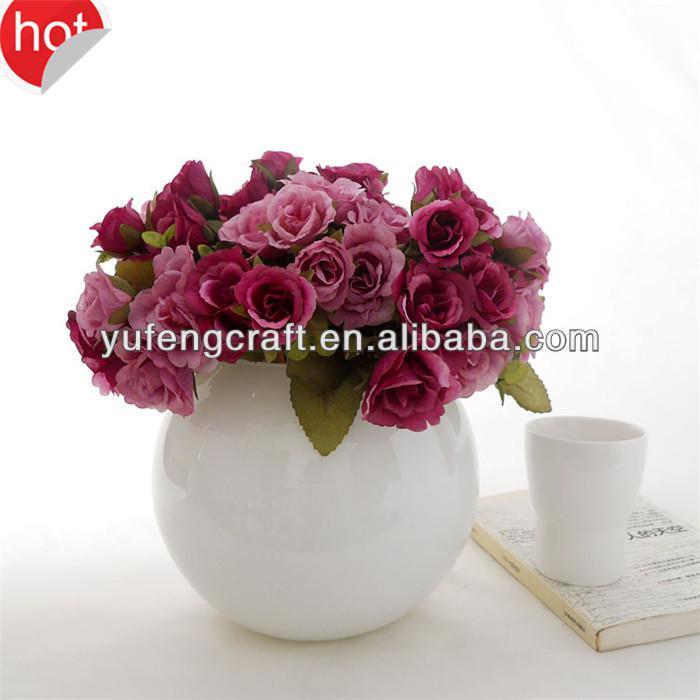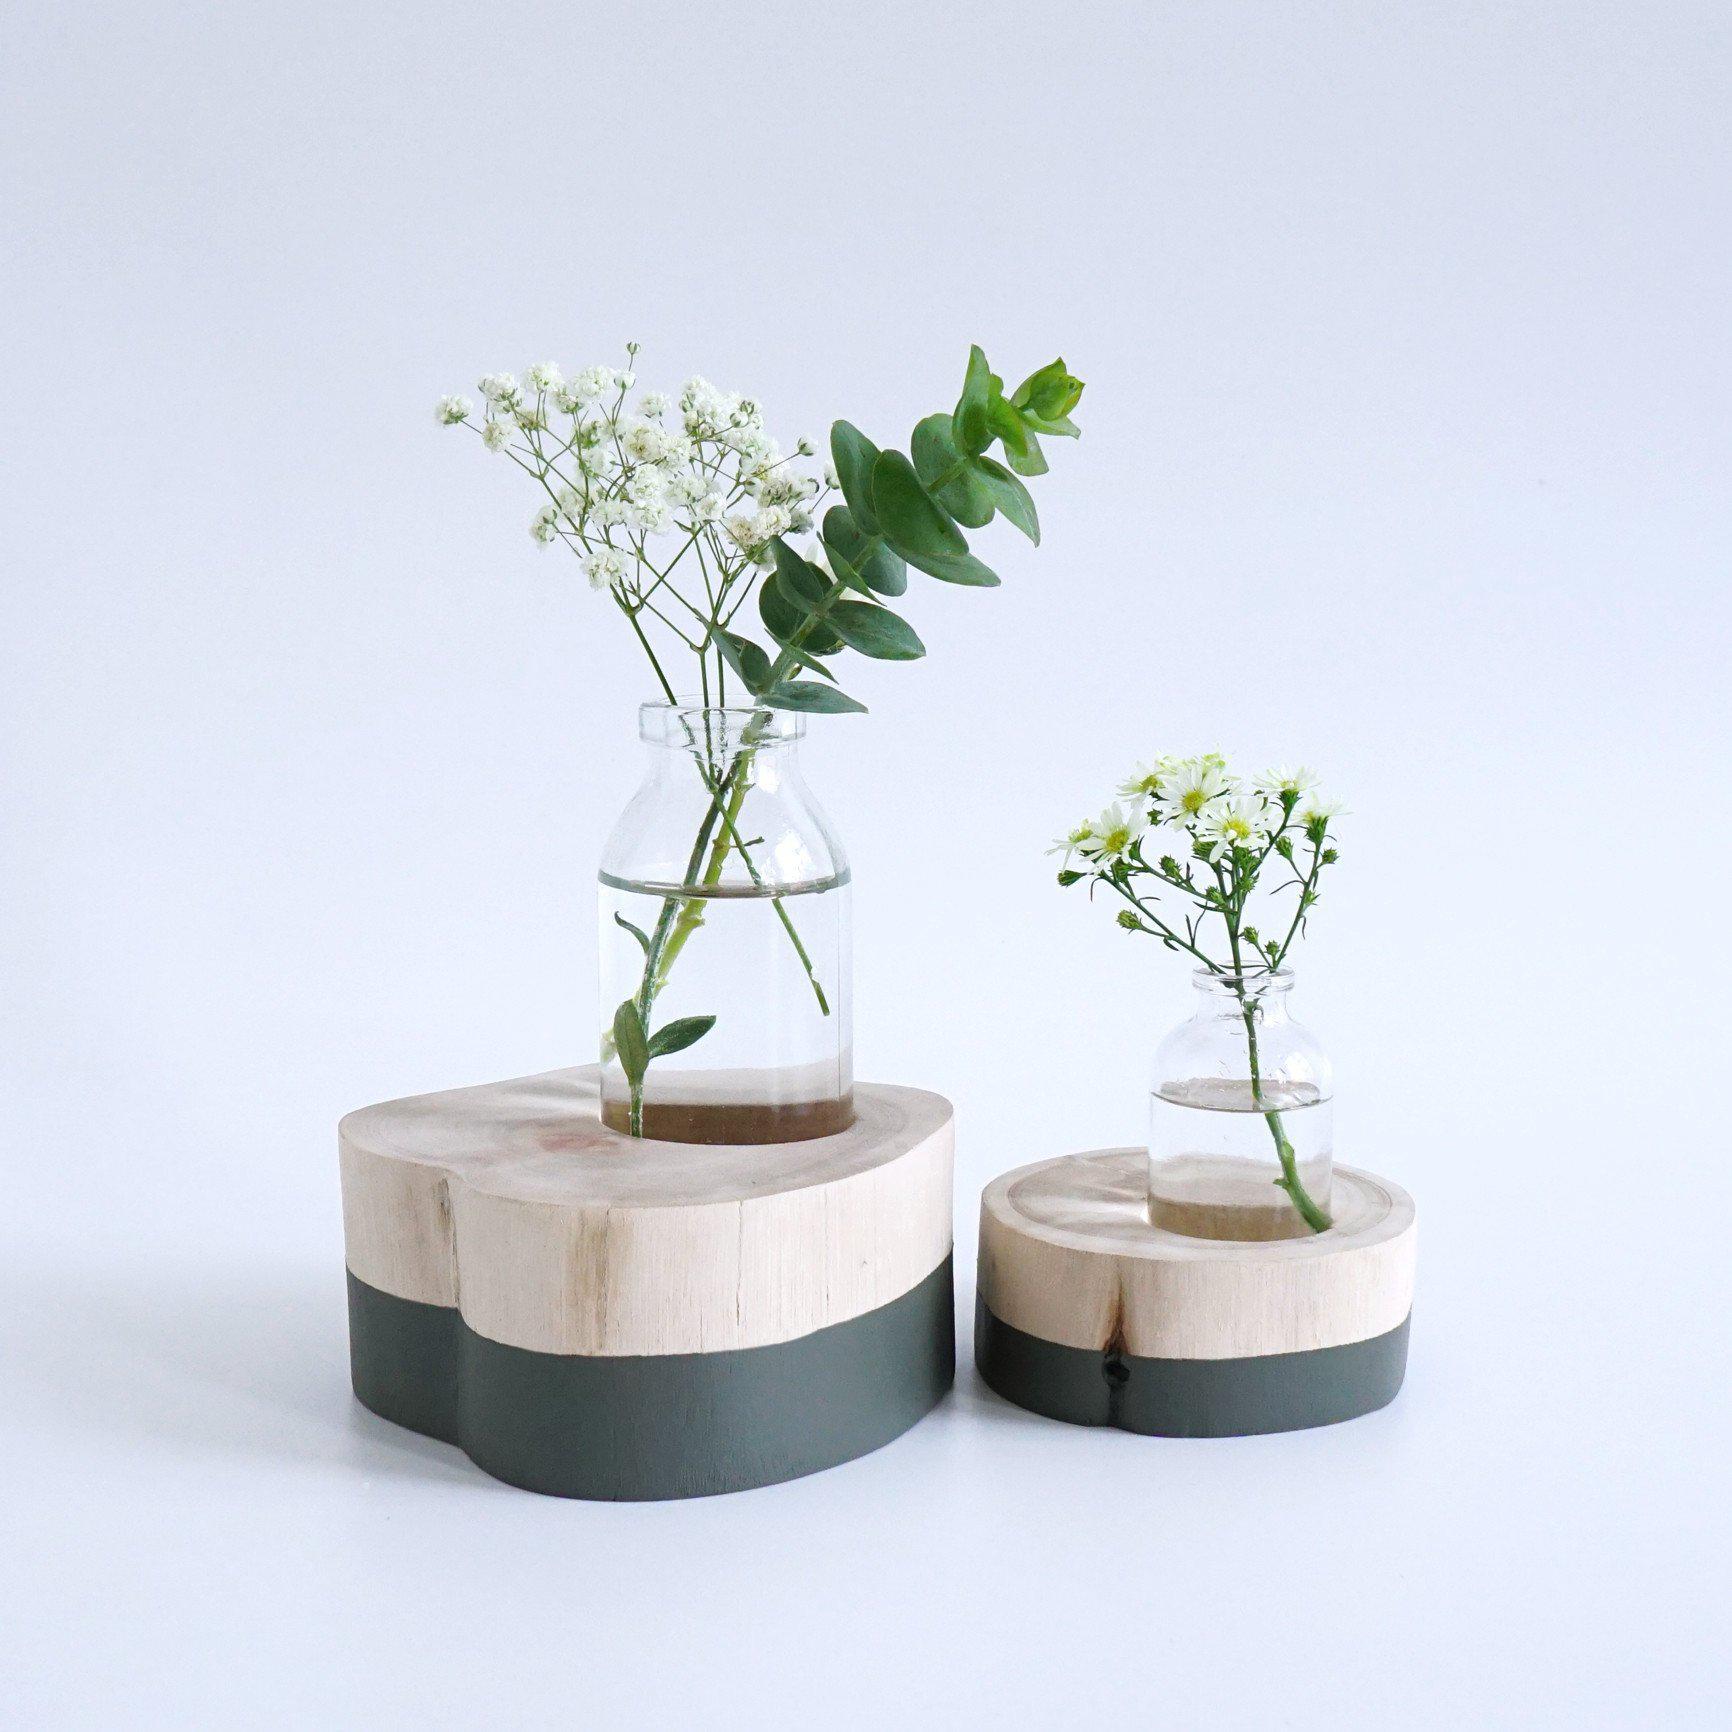The first image is the image on the left, the second image is the image on the right. For the images shown, is this caption "there are pink flowers in a vase" true? Answer yes or no. Yes. 